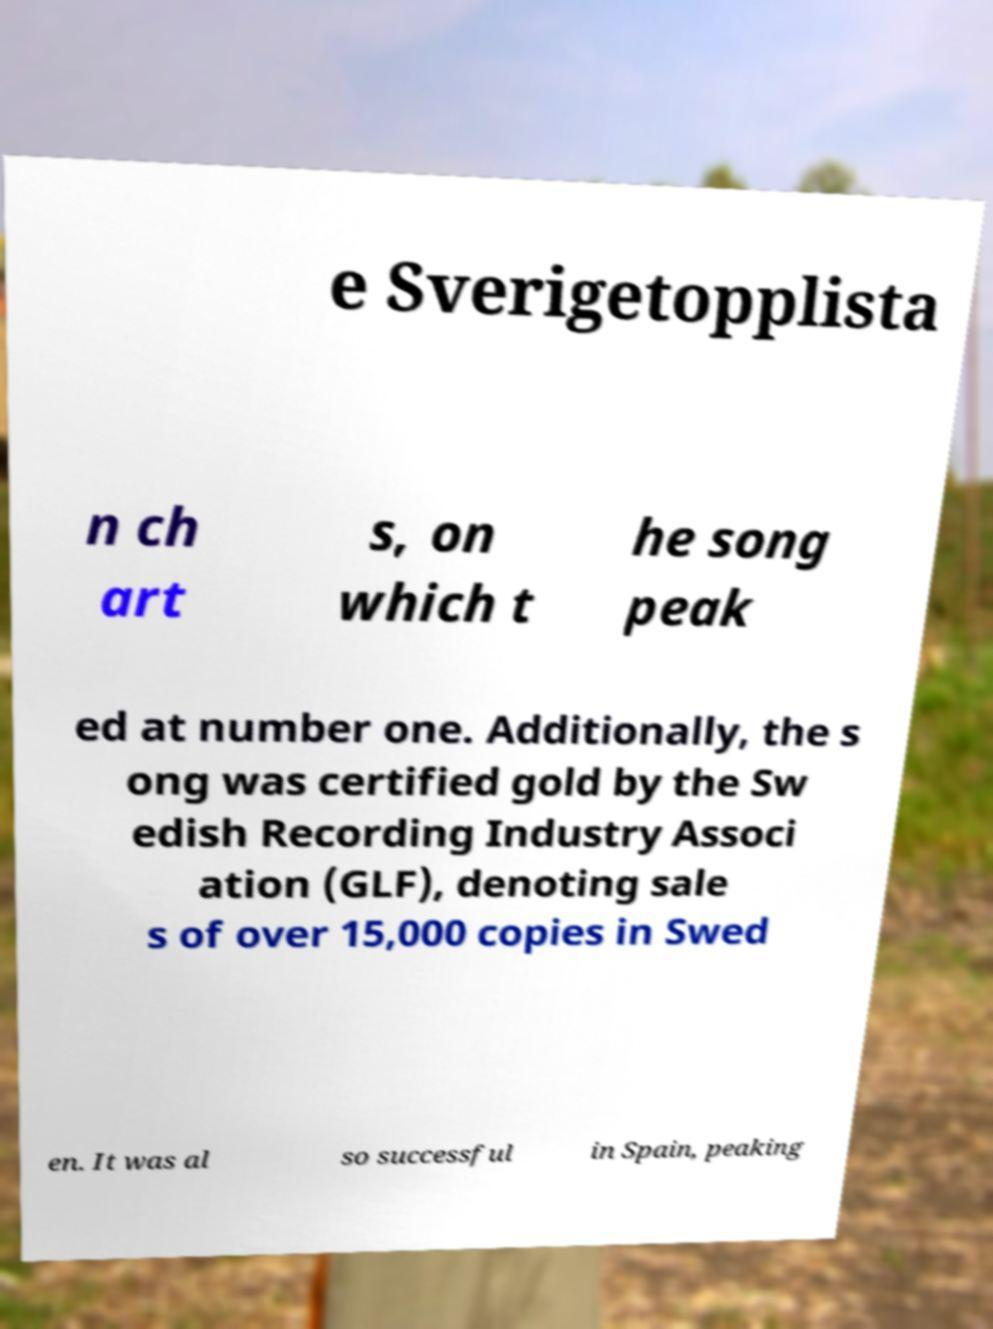Please read and relay the text visible in this image. What does it say? e Sverigetopplista n ch art s, on which t he song peak ed at number one. Additionally, the s ong was certified gold by the Sw edish Recording Industry Associ ation (GLF), denoting sale s of over 15,000 copies in Swed en. It was al so successful in Spain, peaking 